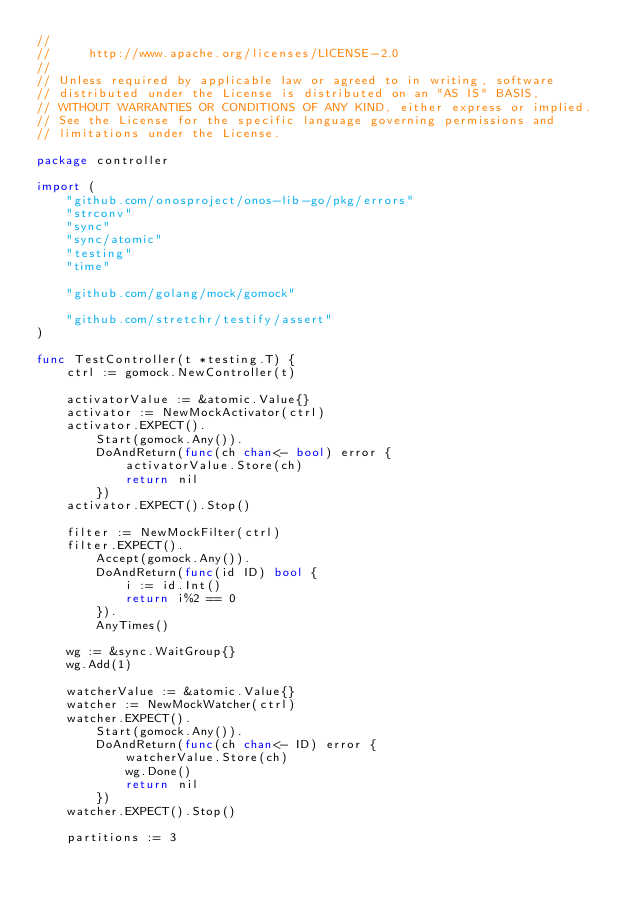<code> <loc_0><loc_0><loc_500><loc_500><_Go_>//
//     http://www.apache.org/licenses/LICENSE-2.0
//
// Unless required by applicable law or agreed to in writing, software
// distributed under the License is distributed on an "AS IS" BASIS,
// WITHOUT WARRANTIES OR CONDITIONS OF ANY KIND, either express or implied.
// See the License for the specific language governing permissions and
// limitations under the License.

package controller

import (
	"github.com/onosproject/onos-lib-go/pkg/errors"
	"strconv"
	"sync"
	"sync/atomic"
	"testing"
	"time"

	"github.com/golang/mock/gomock"

	"github.com/stretchr/testify/assert"
)

func TestController(t *testing.T) {
	ctrl := gomock.NewController(t)

	activatorValue := &atomic.Value{}
	activator := NewMockActivator(ctrl)
	activator.EXPECT().
		Start(gomock.Any()).
		DoAndReturn(func(ch chan<- bool) error {
			activatorValue.Store(ch)
			return nil
		})
	activator.EXPECT().Stop()

	filter := NewMockFilter(ctrl)
	filter.EXPECT().
		Accept(gomock.Any()).
		DoAndReturn(func(id ID) bool {
			i := id.Int()
			return i%2 == 0
		}).
		AnyTimes()

	wg := &sync.WaitGroup{}
	wg.Add(1)

	watcherValue := &atomic.Value{}
	watcher := NewMockWatcher(ctrl)
	watcher.EXPECT().
		Start(gomock.Any()).
		DoAndReturn(func(ch chan<- ID) error {
			watcherValue.Store(ch)
			wg.Done()
			return nil
		})
	watcher.EXPECT().Stop()

	partitions := 3</code> 